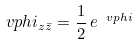Convert formula to latex. <formula><loc_0><loc_0><loc_500><loc_500>\ v p h i _ { z \bar { z } } = \frac { 1 } { 2 } \, e ^ { \ v p h i }</formula> 